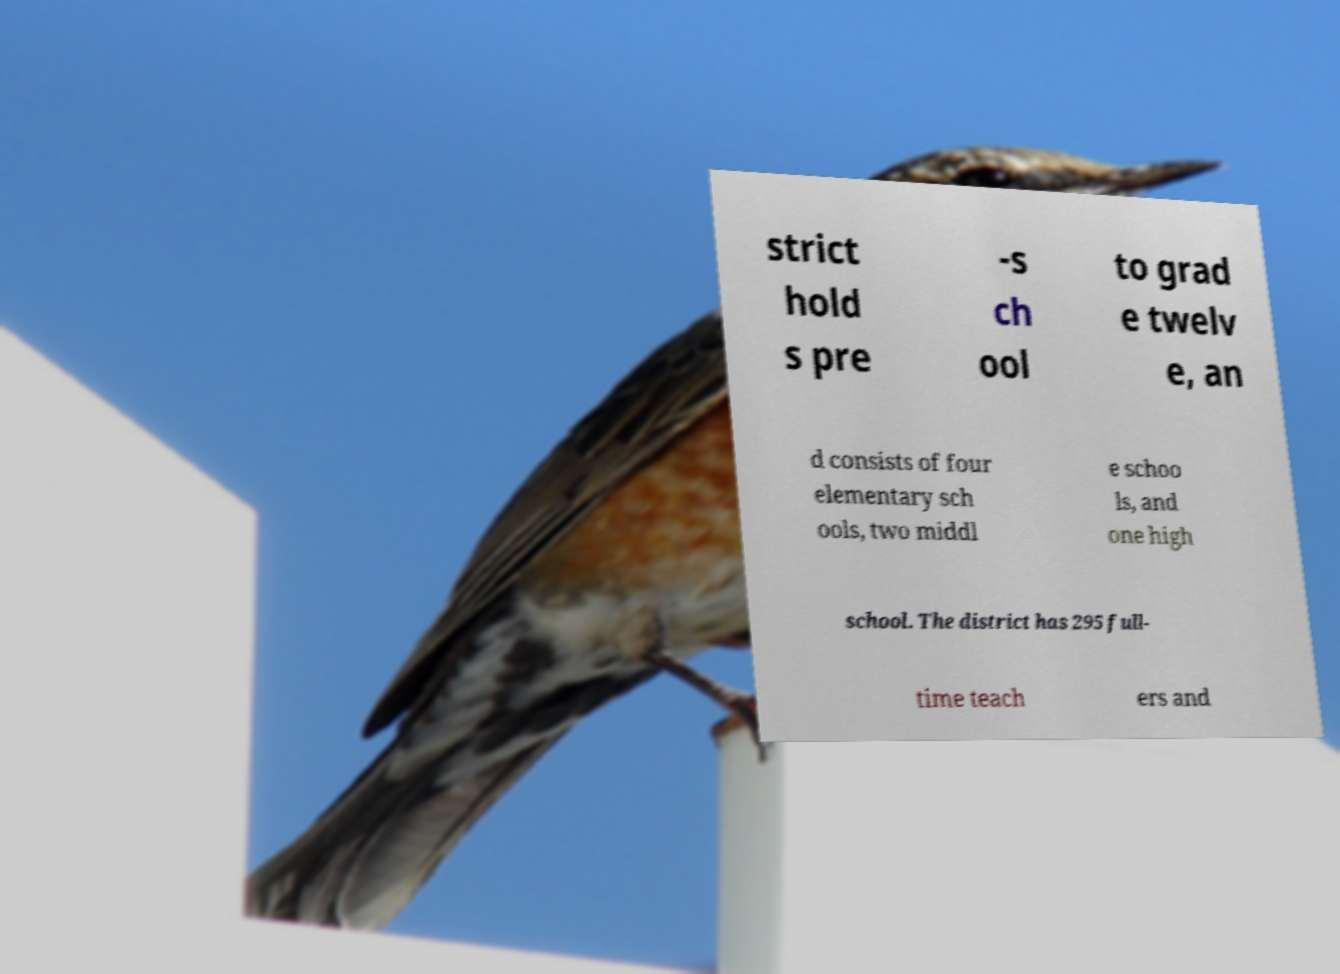Please identify and transcribe the text found in this image. strict hold s pre -s ch ool to grad e twelv e, an d consists of four elementary sch ools, two middl e schoo ls, and one high school. The district has 295 full- time teach ers and 